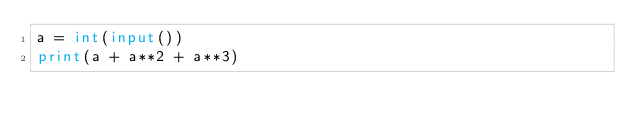Convert code to text. <code><loc_0><loc_0><loc_500><loc_500><_Python_>a = int(input())
print(a + a**2 + a**3)
</code> 